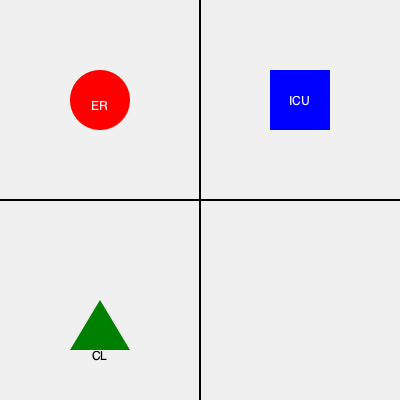Based on the hospital floor plan shown, which symbol represents the Child Life program area? To identify the Child Life program area in the hospital floor plan, let's analyze the symbols:

1. The floor plan is divided into four quadrants.
2. In the top-left quadrant, there's a red circle labeled "ER" (Emergency Room).
3. In the top-right quadrant, there's a blue square labeled "ICU" (Intensive Care Unit).
4. In the bottom-left quadrant, there's a green triangle labeled "CL".
5. The "CL" label likely stands for "Child Life", as it's a common abbreviation in pediatric hospitals.
6. The green triangle symbol is associated with play and growth, which aligns with the Child Life program's goals.

Therefore, the green triangle in the bottom-left quadrant represents the Child Life program area.
Answer: Green triangle 